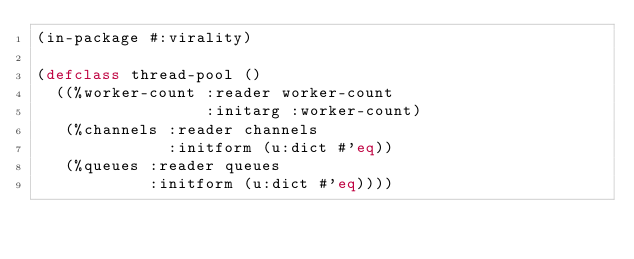<code> <loc_0><loc_0><loc_500><loc_500><_Lisp_>(in-package #:virality)

(defclass thread-pool ()
  ((%worker-count :reader worker-count
                  :initarg :worker-count)
   (%channels :reader channels
              :initform (u:dict #'eq))
   (%queues :reader queues
            :initform (u:dict #'eq))))
</code> 